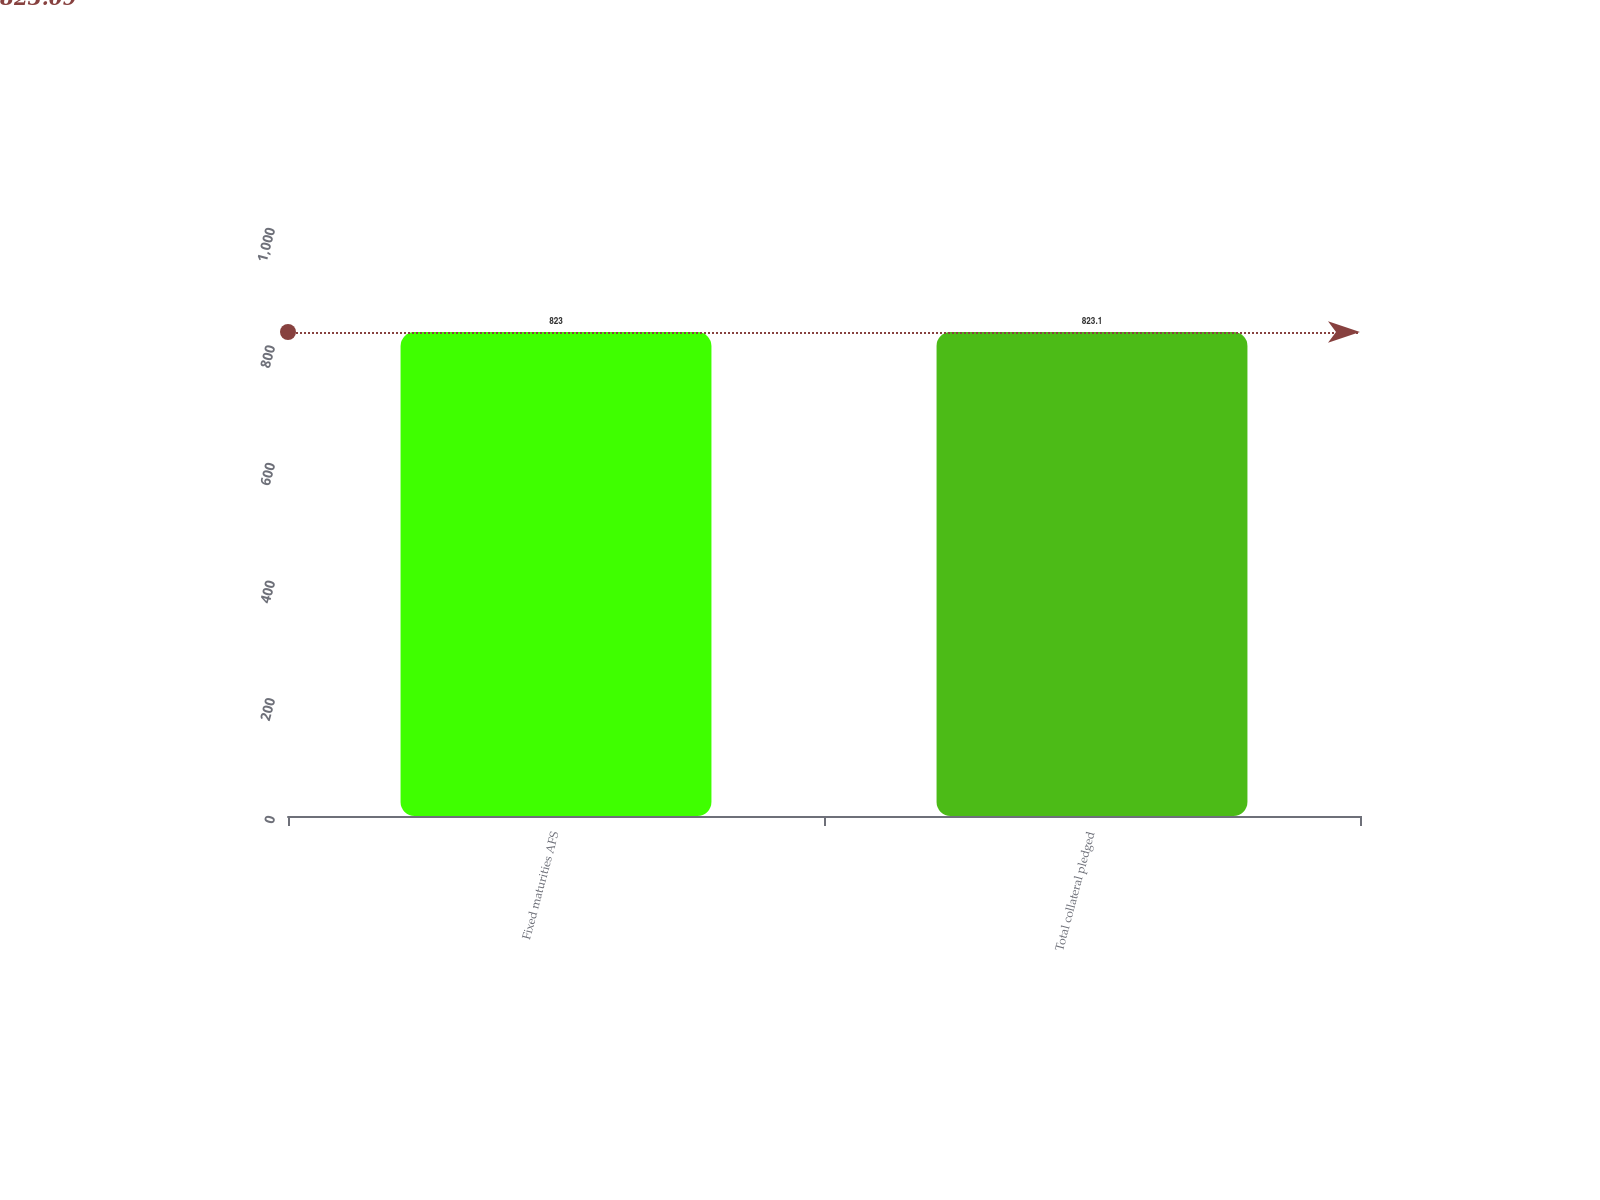<chart> <loc_0><loc_0><loc_500><loc_500><bar_chart><fcel>Fixed maturities AFS<fcel>Total collateral pledged<nl><fcel>823<fcel>823.1<nl></chart> 